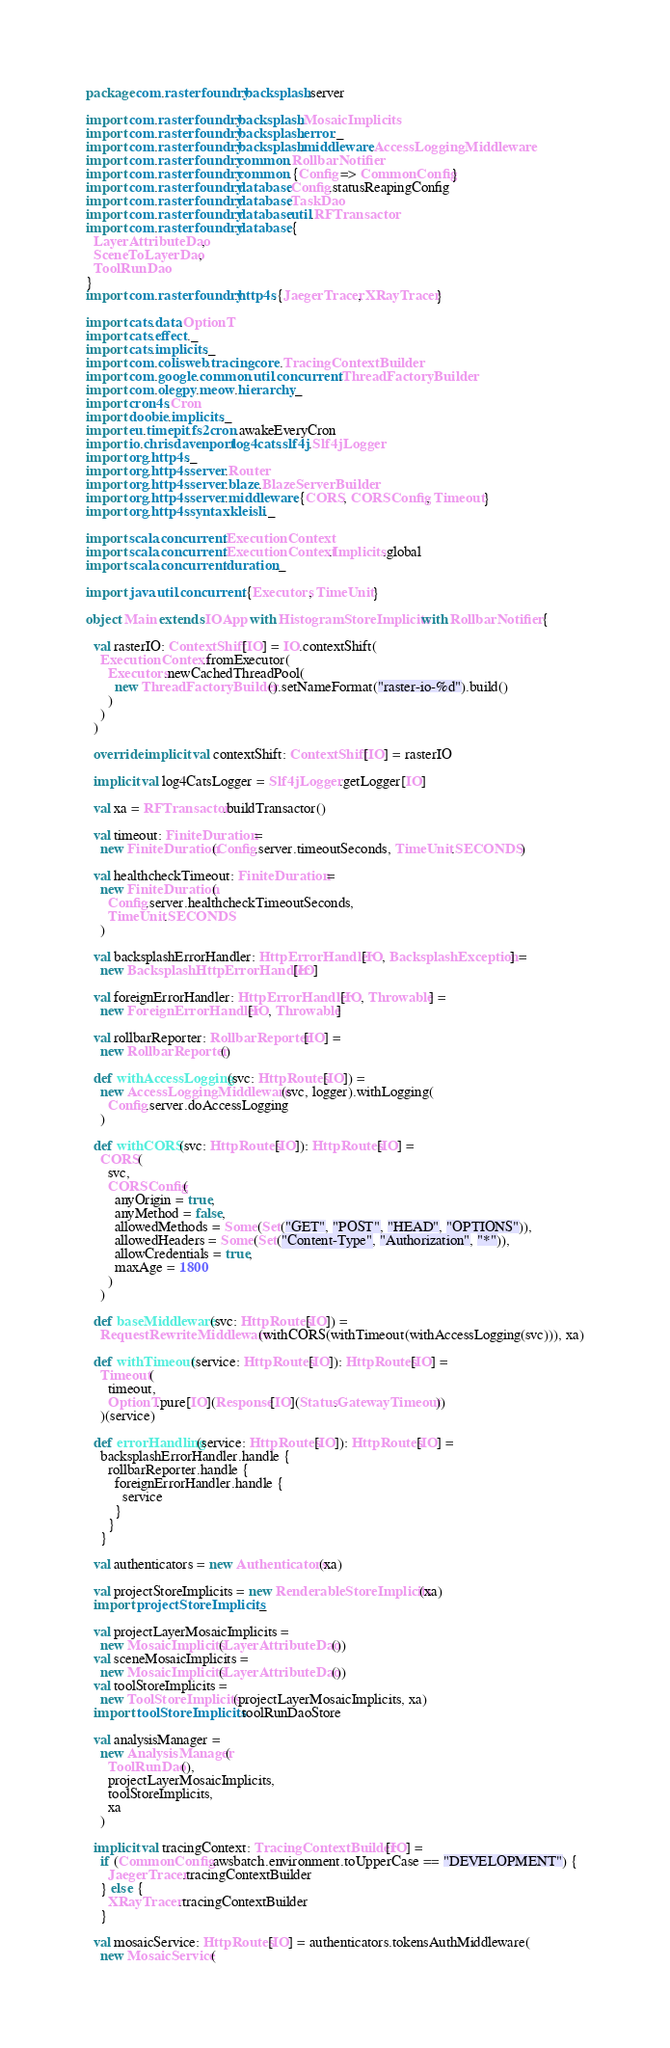Convert code to text. <code><loc_0><loc_0><loc_500><loc_500><_Scala_>package com.rasterfoundry.backsplash.server

import com.rasterfoundry.backsplash.MosaicImplicits
import com.rasterfoundry.backsplash.error._
import com.rasterfoundry.backsplash.middleware.AccessLoggingMiddleware
import com.rasterfoundry.common.RollbarNotifier
import com.rasterfoundry.common.{Config => CommonConfig}
import com.rasterfoundry.database.Config.statusReapingConfig
import com.rasterfoundry.database.TaskDao
import com.rasterfoundry.database.util.RFTransactor
import com.rasterfoundry.database.{
  LayerAttributeDao,
  SceneToLayerDao,
  ToolRunDao
}
import com.rasterfoundry.http4s.{JaegerTracer, XRayTracer}

import cats.data.OptionT
import cats.effect._
import cats.implicits._
import com.colisweb.tracing.core.TracingContextBuilder
import com.google.common.util.concurrent.ThreadFactoryBuilder
import com.olegpy.meow.hierarchy._
import cron4s.Cron
import doobie.implicits._
import eu.timepit.fs2cron.awakeEveryCron
import io.chrisdavenport.log4cats.slf4j.Slf4jLogger
import org.http4s._
import org.http4s.server.Router
import org.http4s.server.blaze.BlazeServerBuilder
import org.http4s.server.middleware.{CORS, CORSConfig, Timeout}
import org.http4s.syntax.kleisli._

import scala.concurrent.ExecutionContext
import scala.concurrent.ExecutionContext.Implicits.global
import scala.concurrent.duration._

import java.util.concurrent.{Executors, TimeUnit}

object Main extends IOApp with HistogramStoreImplicits with RollbarNotifier {

  val rasterIO: ContextShift[IO] = IO.contextShift(
    ExecutionContext.fromExecutor(
      Executors.newCachedThreadPool(
        new ThreadFactoryBuilder().setNameFormat("raster-io-%d").build()
      )
    )
  )

  override implicit val contextShift: ContextShift[IO] = rasterIO

  implicit val log4CatsLogger = Slf4jLogger.getLogger[IO]

  val xa = RFTransactor.buildTransactor()

  val timeout: FiniteDuration =
    new FiniteDuration(Config.server.timeoutSeconds, TimeUnit.SECONDS)

  val healthcheckTimeout: FiniteDuration =
    new FiniteDuration(
      Config.server.healthcheckTimeoutSeconds,
      TimeUnit.SECONDS
    )

  val backsplashErrorHandler: HttpErrorHandler[IO, BacksplashException] =
    new BacksplashHttpErrorHandler[IO]

  val foreignErrorHandler: HttpErrorHandler[IO, Throwable] =
    new ForeignErrorHandler[IO, Throwable]

  val rollbarReporter: RollbarReporter[IO] =
    new RollbarReporter()

  def withAccessLogging(svc: HttpRoutes[IO]) =
    new AccessLoggingMiddleware(svc, logger).withLogging(
      Config.server.doAccessLogging
    )

  def withCORS(svc: HttpRoutes[IO]): HttpRoutes[IO] =
    CORS(
      svc,
      CORSConfig(
        anyOrigin = true,
        anyMethod = false,
        allowedMethods = Some(Set("GET", "POST", "HEAD", "OPTIONS")),
        allowedHeaders = Some(Set("Content-Type", "Authorization", "*")),
        allowCredentials = true,
        maxAge = 1800
      )
    )

  def baseMiddleware(svc: HttpRoutes[IO]) =
    RequestRewriteMiddleware(withCORS(withTimeout(withAccessLogging(svc))), xa)

  def withTimeout(service: HttpRoutes[IO]): HttpRoutes[IO] =
    Timeout(
      timeout,
      OptionT.pure[IO](Response[IO](Status.GatewayTimeout))
    )(service)

  def errorHandling(service: HttpRoutes[IO]): HttpRoutes[IO] =
    backsplashErrorHandler.handle {
      rollbarReporter.handle {
        foreignErrorHandler.handle {
          service
        }
      }
    }

  val authenticators = new Authenticators(xa)

  val projectStoreImplicits = new RenderableStoreImplicits(xa)
  import projectStoreImplicits._

  val projectLayerMosaicImplicits =
    new MosaicImplicits(LayerAttributeDao())
  val sceneMosaicImplicits =
    new MosaicImplicits(LayerAttributeDao())
  val toolStoreImplicits =
    new ToolStoreImplicits(projectLayerMosaicImplicits, xa)
  import toolStoreImplicits.toolRunDaoStore

  val analysisManager =
    new AnalysisManager(
      ToolRunDao(),
      projectLayerMosaicImplicits,
      toolStoreImplicits,
      xa
    )

  implicit val tracingContext: TracingContextBuilder[IO] =
    if (CommonConfig.awsbatch.environment.toUpperCase == "DEVELOPMENT") {
      JaegerTracer.tracingContextBuilder
    } else {
      XRayTracer.tracingContextBuilder
    }

  val mosaicService: HttpRoutes[IO] = authenticators.tokensAuthMiddleware(
    new MosaicService(</code> 